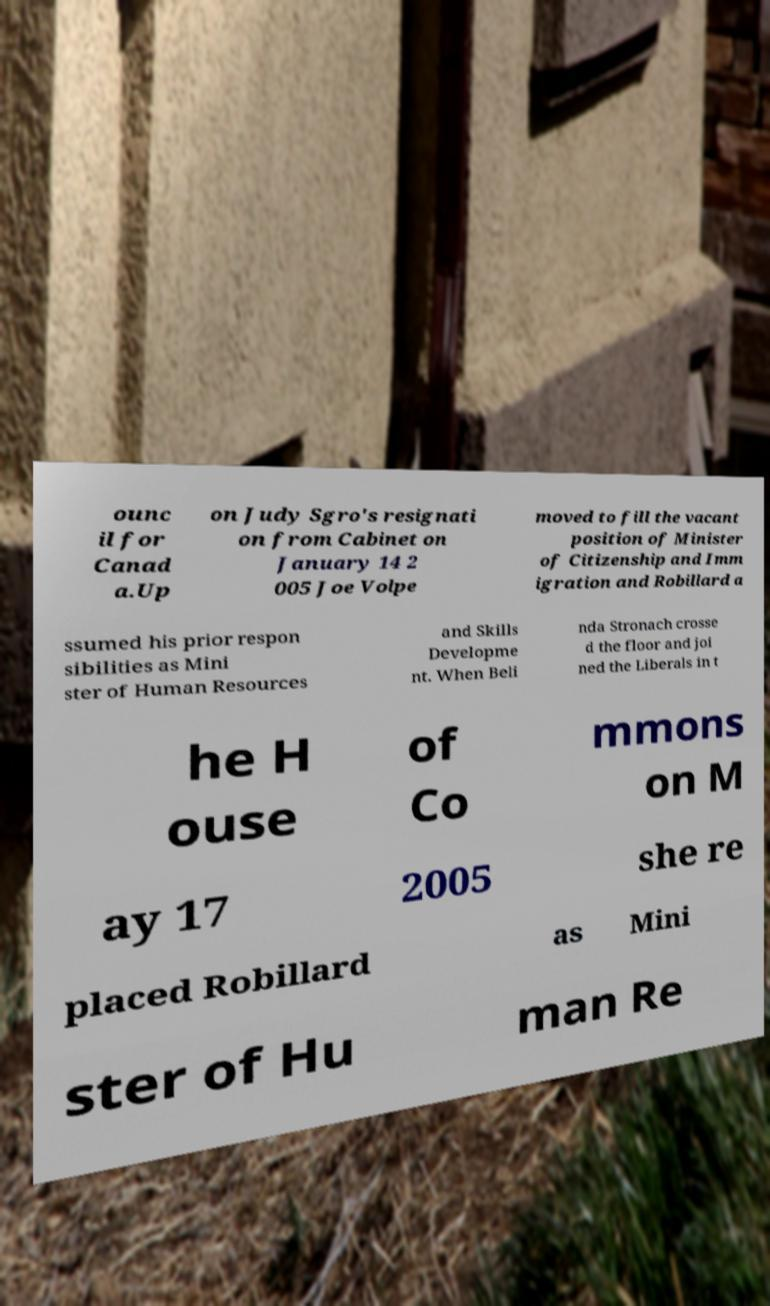For documentation purposes, I need the text within this image transcribed. Could you provide that? ounc il for Canad a.Up on Judy Sgro's resignati on from Cabinet on January 14 2 005 Joe Volpe moved to fill the vacant position of Minister of Citizenship and Imm igration and Robillard a ssumed his prior respon sibilities as Mini ster of Human Resources and Skills Developme nt. When Beli nda Stronach crosse d the floor and joi ned the Liberals in t he H ouse of Co mmons on M ay 17 2005 she re placed Robillard as Mini ster of Hu man Re 